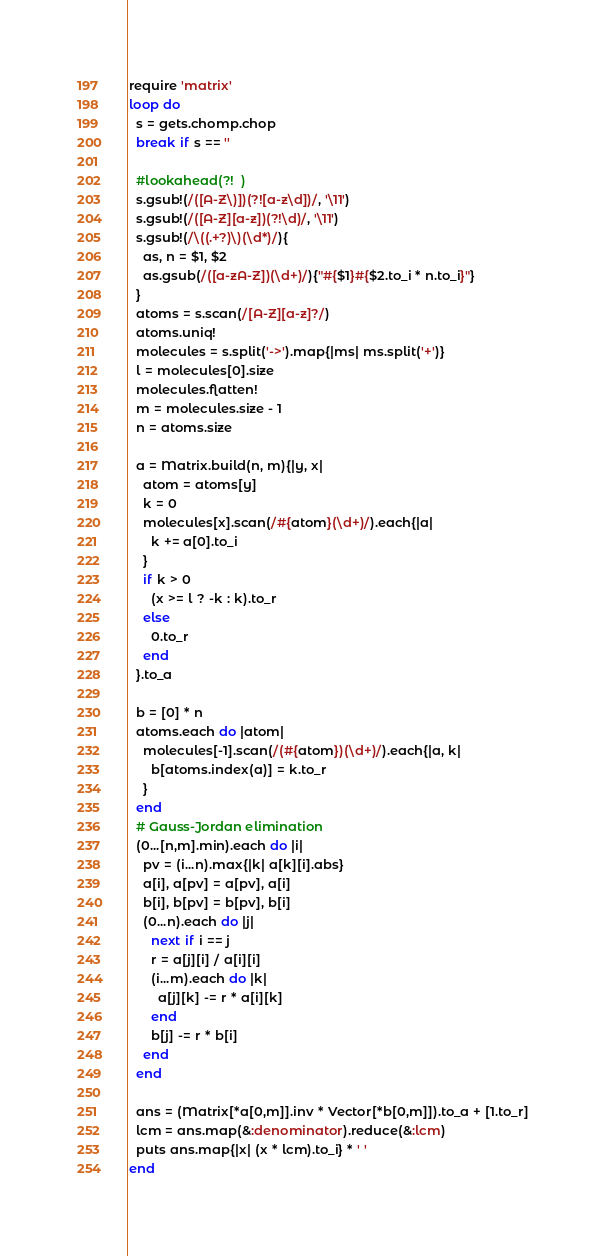Convert code to text. <code><loc_0><loc_0><loc_500><loc_500><_Ruby_>require 'matrix'
loop do
  s = gets.chomp.chop
  break if s == ''

  #lookahead(?!  )
  s.gsub!(/([A-Z\)])(?![a-z\d])/, '\11')
  s.gsub!(/([A-Z][a-z])(?!\d)/, '\11')
  s.gsub!(/\((.+?)\)(\d*)/){
    as, n = $1, $2
    as.gsub(/([a-zA-Z])(\d+)/){"#{$1}#{$2.to_i * n.to_i}"}
  }
  atoms = s.scan(/[A-Z][a-z]?/)
  atoms.uniq!
  molecules = s.split('->').map{|ms| ms.split('+')}
  l = molecules[0].size
  molecules.flatten!
  m = molecules.size - 1
  n = atoms.size

  a = Matrix.build(n, m){|y, x|
    atom = atoms[y]
    k = 0
    molecules[x].scan(/#{atom}(\d+)/).each{|a|
      k += a[0].to_i
    }
    if k > 0
      (x >= l ? -k : k).to_r
    else
      0.to_r
    end
  }.to_a

  b = [0] * n
  atoms.each do |atom|
    molecules[-1].scan(/(#{atom})(\d+)/).each{|a, k|
      b[atoms.index(a)] = k.to_r
    }
  end
  # Gauss-Jordan elimination
  (0...[n,m].min).each do |i|
    pv = (i...n).max{|k| a[k][i].abs}
    a[i], a[pv] = a[pv], a[i]
    b[i], b[pv] = b[pv], b[i]
    (0...n).each do |j|
      next if i == j
      r = a[j][i] / a[i][i]
      (i...m).each do |k|
        a[j][k] -= r * a[i][k]
      end
      b[j] -= r * b[i]
    end
  end

  ans = (Matrix[*a[0,m]].inv * Vector[*b[0,m]]).to_a + [1.to_r]
  lcm = ans.map(&:denominator).reduce(&:lcm)
  puts ans.map{|x| (x * lcm).to_i} * ' '
end</code> 